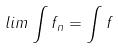Convert formula to latex. <formula><loc_0><loc_0><loc_500><loc_500>l i m \int f _ { n } = \int f</formula> 